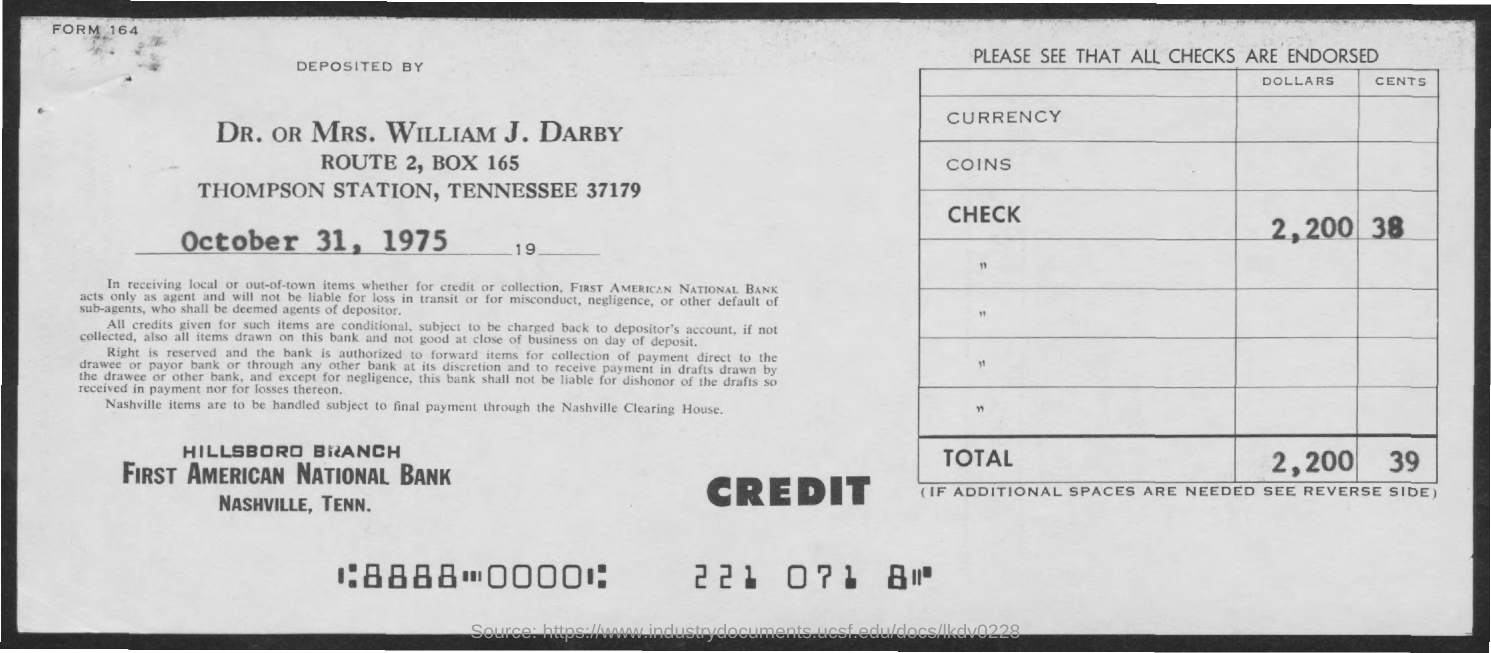Indicate a few pertinent items in this graphic. The date mentioned in this document is October 31, 1975. The total amount is 2,200 to 3,900. 